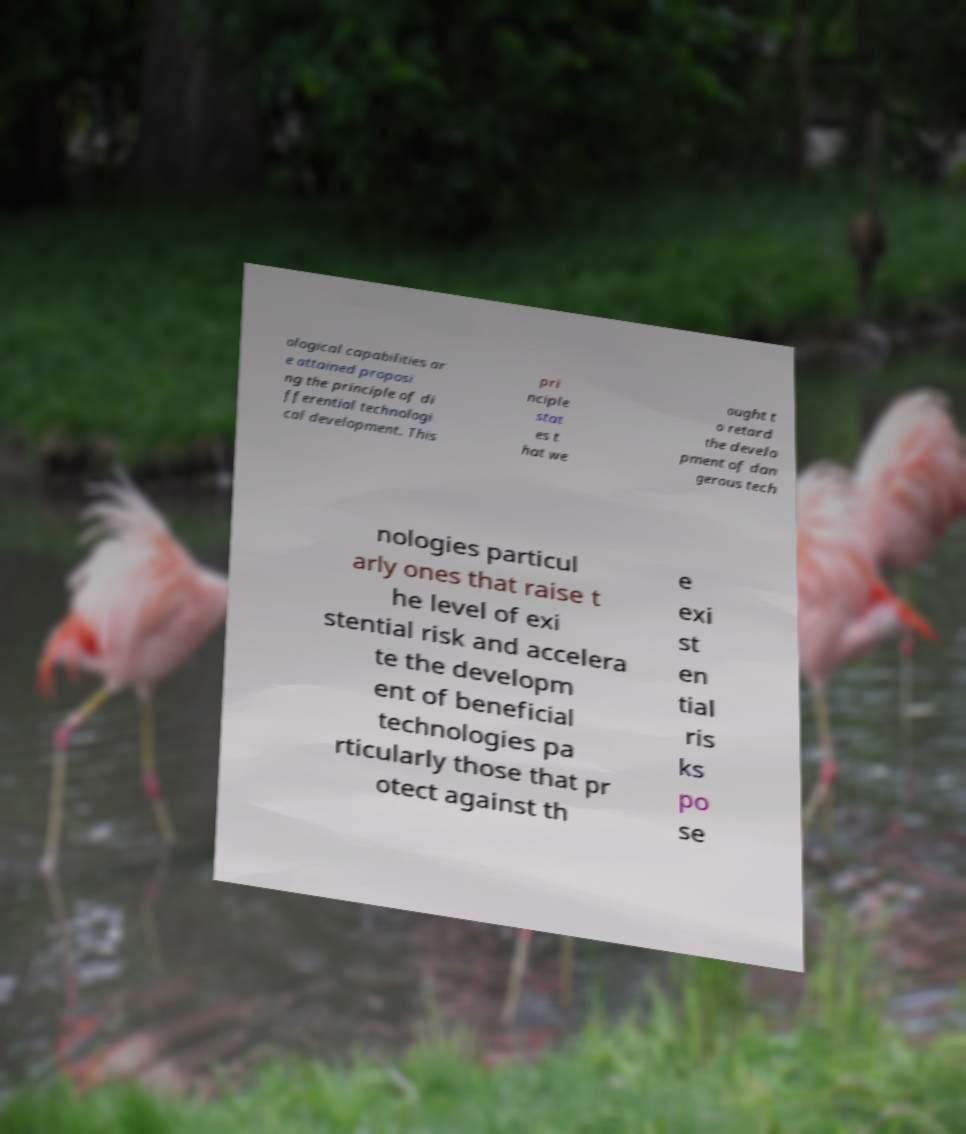Please identify and transcribe the text found in this image. ological capabilities ar e attained proposi ng the principle of di fferential technologi cal development. This pri nciple stat es t hat we ought t o retard the develo pment of dan gerous tech nologies particul arly ones that raise t he level of exi stential risk and accelera te the developm ent of beneficial technologies pa rticularly those that pr otect against th e exi st en tial ris ks po se 